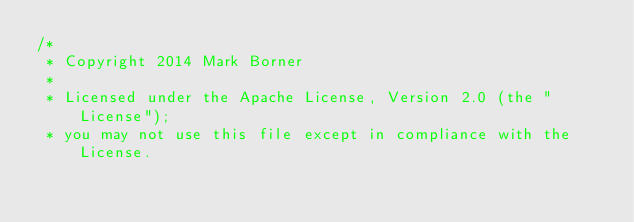Convert code to text. <code><loc_0><loc_0><loc_500><loc_500><_Java_>/*
 * Copyright 2014 Mark Borner
 *
 * Licensed under the Apache License, Version 2.0 (the "License");
 * you may not use this file except in compliance with the License.</code> 